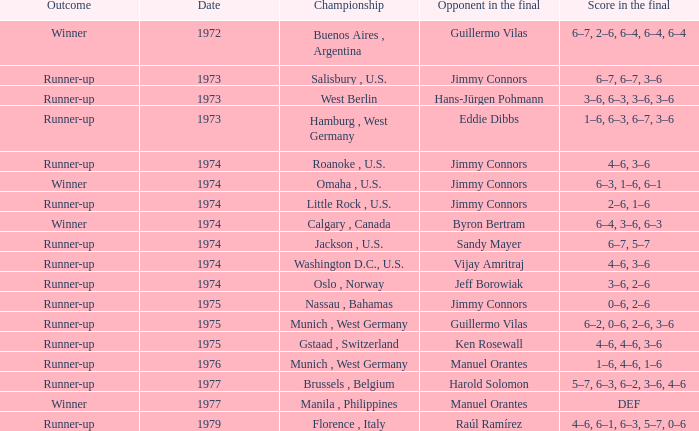What was the final score with Guillermo Vilas as the opponent in the final, that happened after 1972? 6–2, 0–6, 2–6, 3–6. 